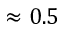Convert formula to latex. <formula><loc_0><loc_0><loc_500><loc_500>\approx 0 . 5</formula> 